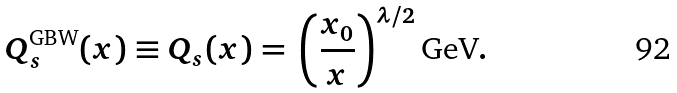Convert formula to latex. <formula><loc_0><loc_0><loc_500><loc_500>Q _ { s } ^ { \text {GBW} } ( x ) \equiv Q _ { s } ( x ) = \, \left ( \frac { x _ { 0 } } { x } \right ) ^ { \lambda / 2 } \text {GeV} .</formula> 